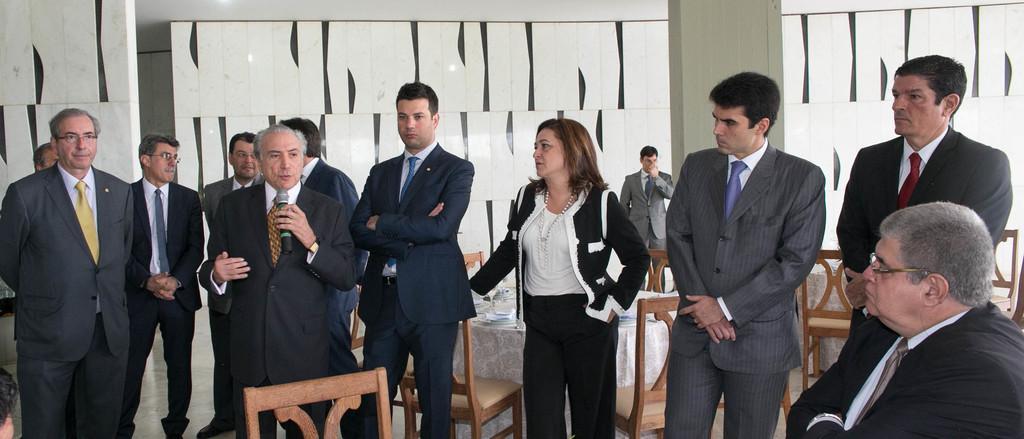How would you summarize this image in a sentence or two? In the center of the image there is a person standing talking in a mic beside him there are people standing. There are chairs. In the background of the image there is wall. 